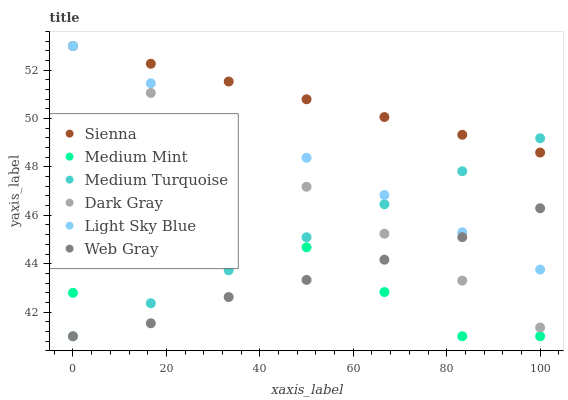Does Medium Mint have the minimum area under the curve?
Answer yes or no. Yes. Does Sienna have the maximum area under the curve?
Answer yes or no. Yes. Does Dark Gray have the minimum area under the curve?
Answer yes or no. No. Does Dark Gray have the maximum area under the curve?
Answer yes or no. No. Is Light Sky Blue the smoothest?
Answer yes or no. Yes. Is Medium Mint the roughest?
Answer yes or no. Yes. Is Dark Gray the smoothest?
Answer yes or no. No. Is Dark Gray the roughest?
Answer yes or no. No. Does Medium Mint have the lowest value?
Answer yes or no. Yes. Does Dark Gray have the lowest value?
Answer yes or no. No. Does Light Sky Blue have the highest value?
Answer yes or no. Yes. Does Web Gray have the highest value?
Answer yes or no. No. Is Medium Mint less than Light Sky Blue?
Answer yes or no. Yes. Is Dark Gray greater than Medium Mint?
Answer yes or no. Yes. Does Dark Gray intersect Light Sky Blue?
Answer yes or no. Yes. Is Dark Gray less than Light Sky Blue?
Answer yes or no. No. Is Dark Gray greater than Light Sky Blue?
Answer yes or no. No. Does Medium Mint intersect Light Sky Blue?
Answer yes or no. No. 